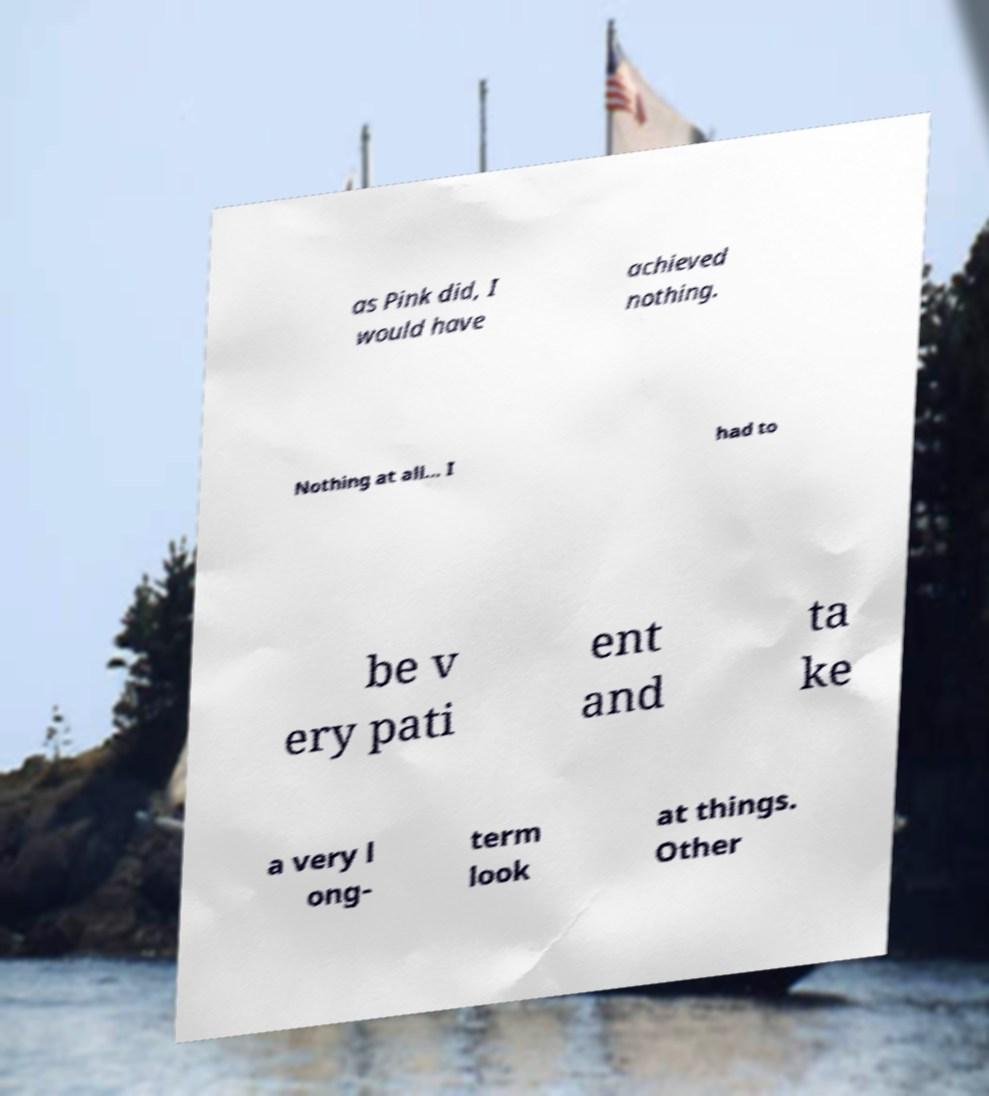Please identify and transcribe the text found in this image. as Pink did, I would have achieved nothing. Nothing at all... I had to be v ery pati ent and ta ke a very l ong- term look at things. Other 